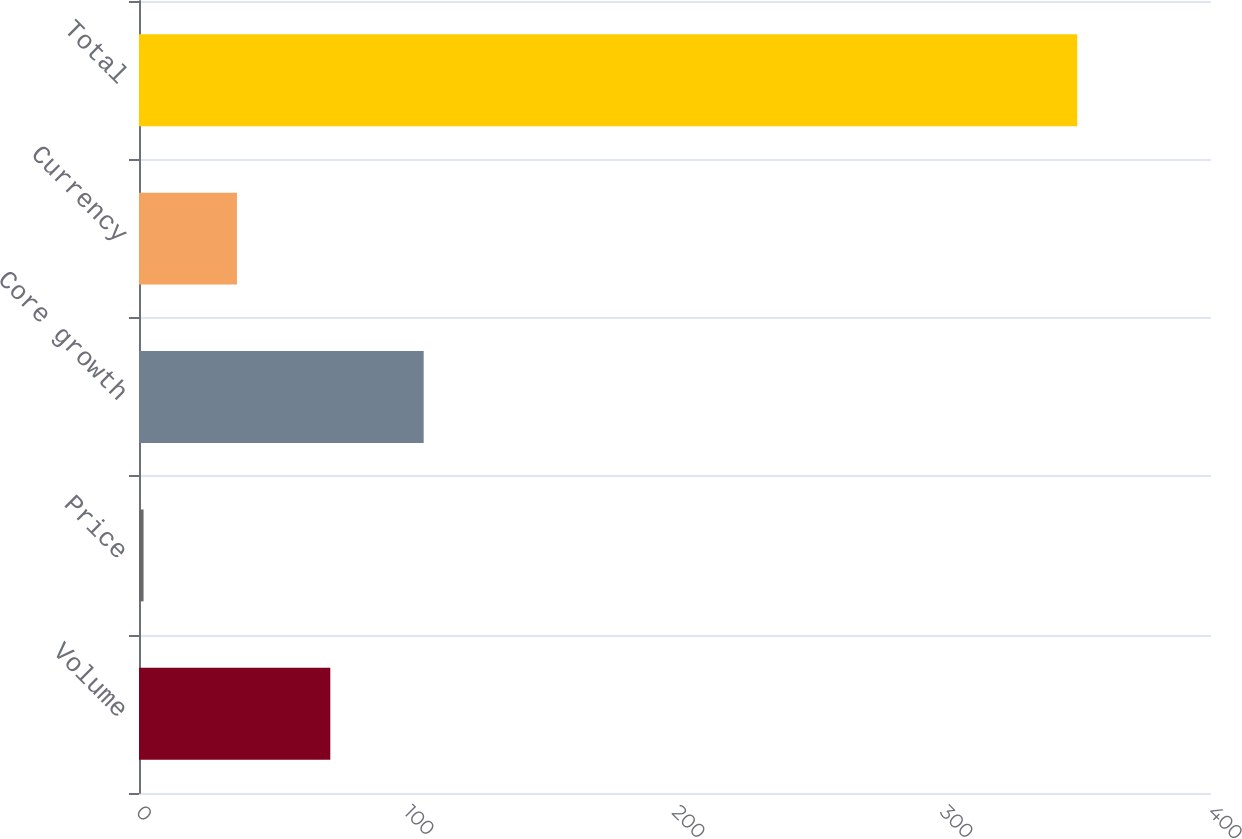Convert chart to OTSL. <chart><loc_0><loc_0><loc_500><loc_500><bar_chart><fcel>Volume<fcel>Price<fcel>Core growth<fcel>Currency<fcel>Total<nl><fcel>71.38<fcel>1.7<fcel>106.22<fcel>36.54<fcel>350.1<nl></chart> 